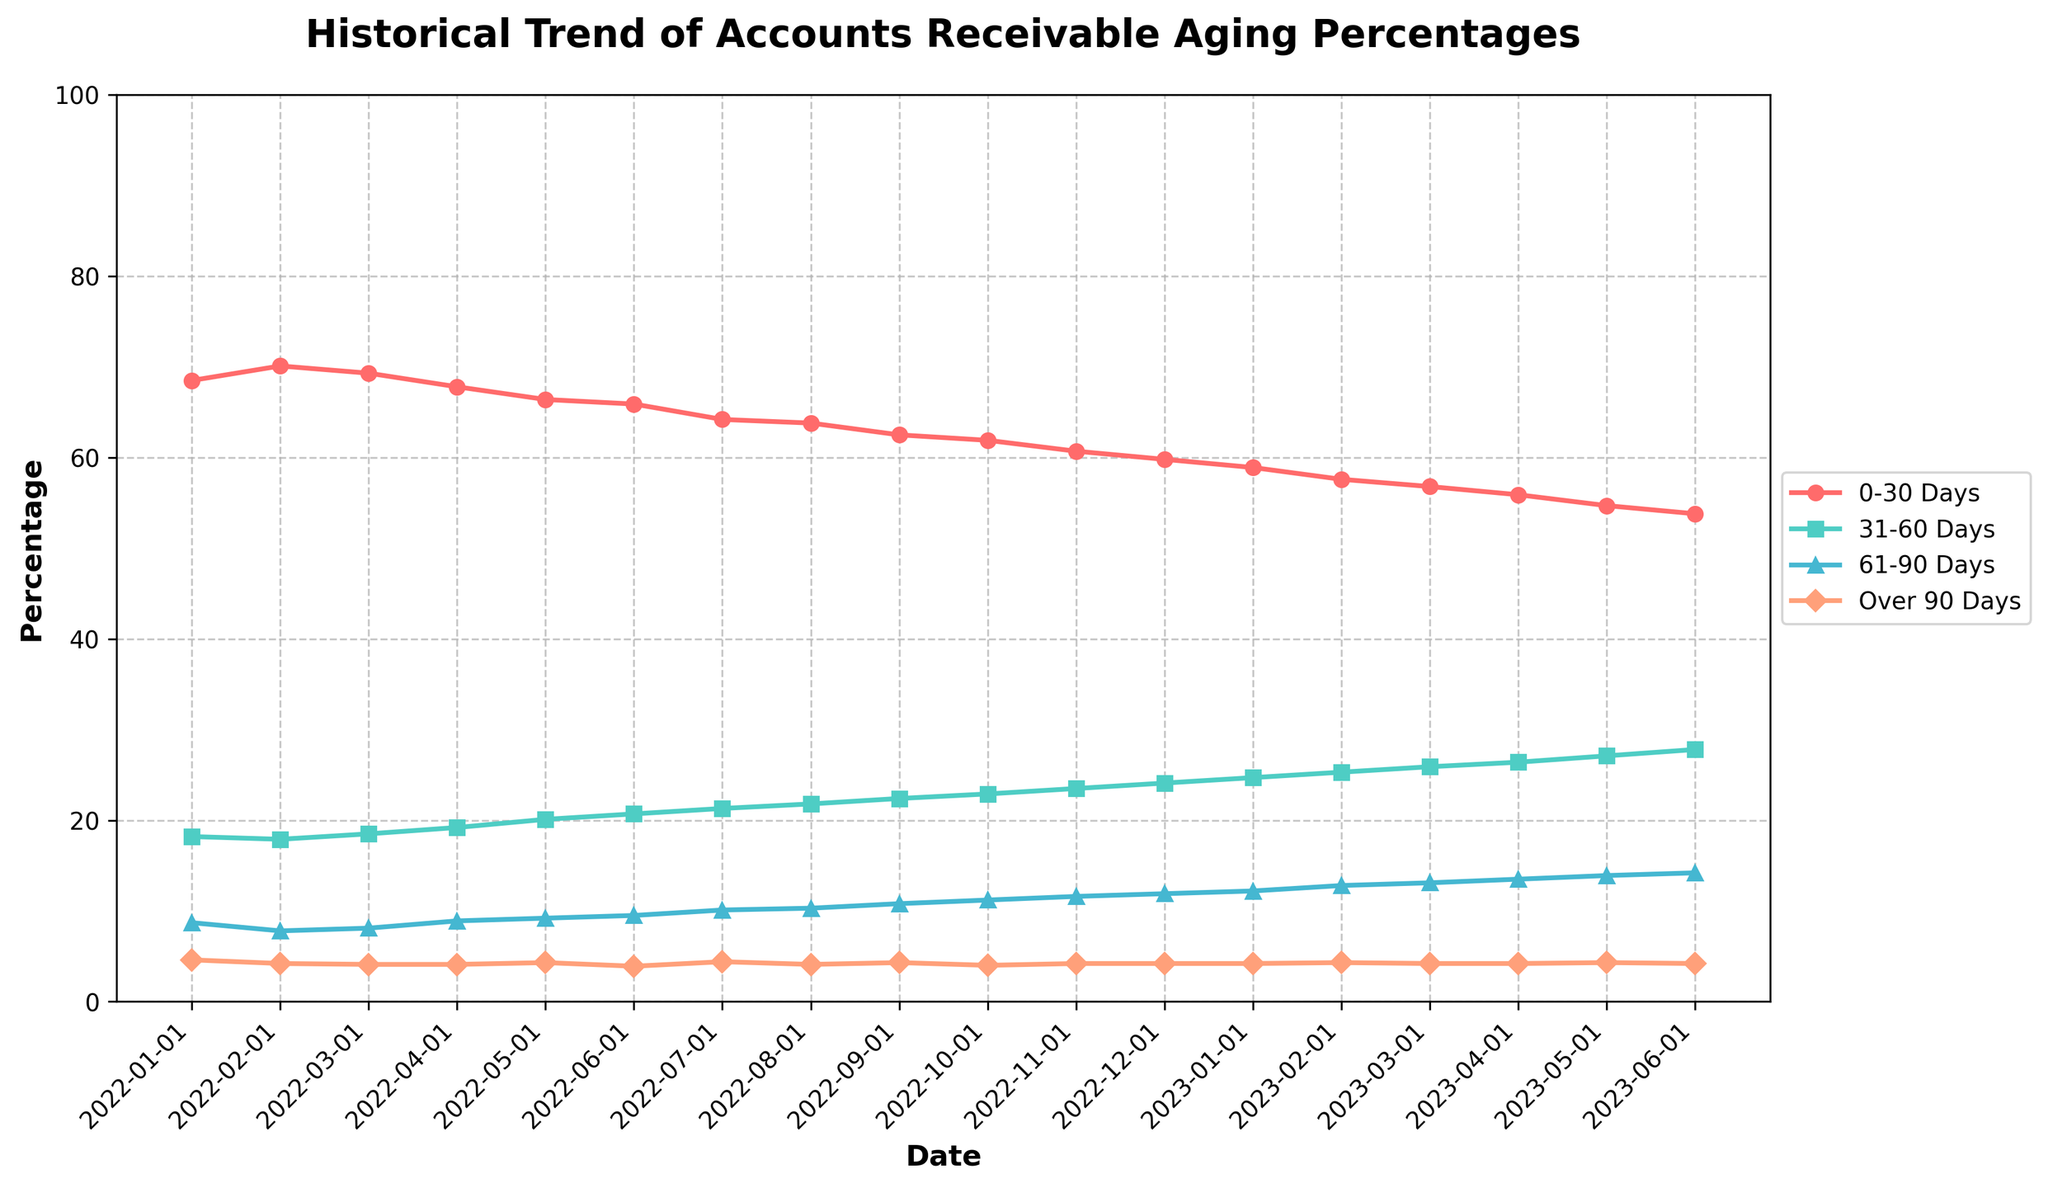What's the average percentage for the 0-30 Days category over the entire period? To find the average percentage for the 0-30 Days category, sum all the percentages for this category and divide by the number of data points. The sums are 68.5 + 70.1 + 69.3 + 67.8 + 66.4 + 65.9 + 64.2 + 63.8 + 62.5 + 61.9 + 60.7 + 59.8 + 58.9 + 57.6 + 56.8 + 55.9 + 54.7 + 53.8 which equal 1138.8. There are 18 data points. So, the average = 1138.8 / 18 = 63.27
Answer: 63.27 During which month did the Over 90 Days category reach its lowest percentage, and what was that percentage? To find the lowest percentage, inspect the over 90 Days trend line visually and identify the lowest point on the graph. According to the data, the lowest percentage is 3.9, which occurred in June 2022.
Answer: June 2022, 3.9 How does the percentage for the 61-90 Days category in June 2023 compare to January 2022? Check the percentages for the 61-90 Days category in June 2023 and January 2022 from the data. For June 2023, it’s 14.2, and for January 2022, it’s 8.7. Comparing them, June 2023 is higher than January 2022.
Answer: Higher What is the trend observed for the percentage of 31-60 Days from January 2022 to June 2023? Observe the plotted line for the 31-60 Days category from January 2022 to June 2023. The trend shows a steady increase over the period, starting from 18.2 and increasing to 27.8.
Answer: Increasing Which category has the most significant increase over the observed period? Compare the differences in percentages for each category from January 2022 to June 2023. Calculate the increase for each category. 0-30 Days: 53.8 - 68.5 = -14.7, 31-60 Days: 27.8 - 18.2 = 9.6, 61-90 Days: 14.2 - 8.7 = 5.5, Over 90 Days: 4.2 - 4.6 = -0.4. The 31-60 Days category has the highest increase of 9.6 percentage points.
Answer: 31-60 Days During which months do the percentages of all categories (0-30, 31-60, 61-90, Over 90) sum up to exactly 100%? Calculate the sum of percentages for each month and identify those that equal 100%. All the months sum to 100% as per the defined data ranges since percentages should cover the entire aging of accounts receivable.
Answer: Every Month What was the percentage difference between the 0-30 Days category from the start and end of the period? Identify the percentages for the 0-30 Days category at the start (January 2022) and end (June 2023) from the data. The start percentage is 68.5 and the end percentage is 53.8. The difference is 68.5 - 53.8 = 14.7 percentage points.
Answer: 14.7 What is the visual pattern for the Over 90 Days category throughout the given timeframe? Observe the line representing the Over 90 Days category. The pattern shows slight fluctuations but generally stays relatively stable around the 4% mark, reaching just below 4% in some months and slightly above in others.
Answer: Relatively stable around 4% Which month has the highest percentage for the 31-60 Days category, and what is the value? Locate the peak point on the 31-60 Days trend line. According to the data, the highest percentage is in June 2023 with a value of 27.8%.
Answer: June 2023, 27.8 Is there any overlap between the 61-90 Days and Over 90 Days categories in terms of their trend lines? Visually inspect for any points where the lines for 61-90 Days and Over 90 Days cross or are very close to each other. The lines do not overlap; the 61-90 Days line is consistently higher than the Over 90 Days line.
Answer: No 